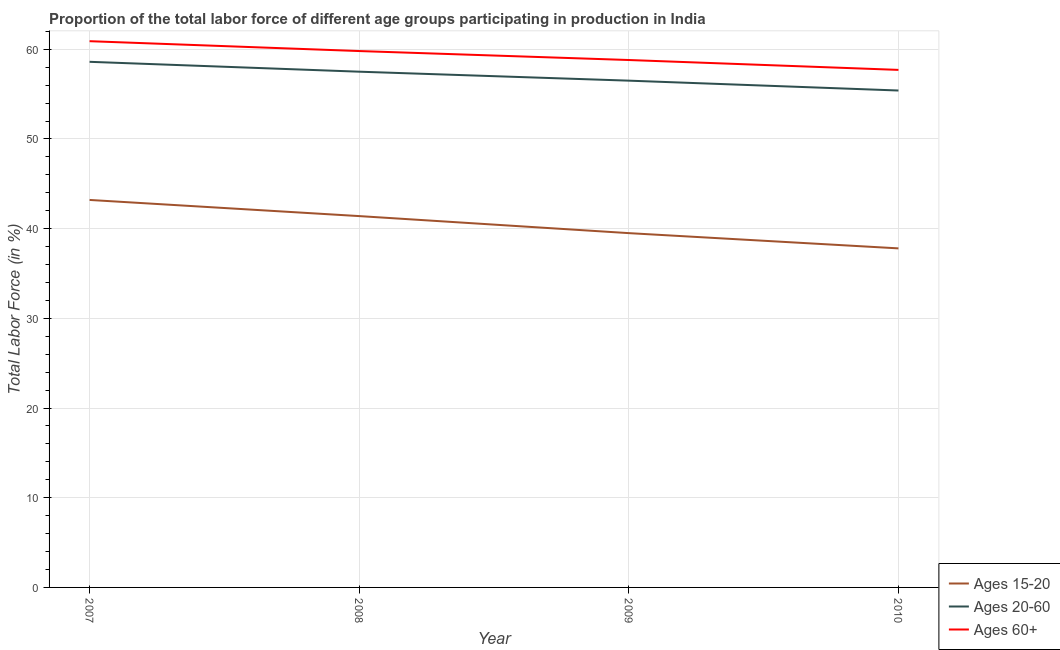How many different coloured lines are there?
Offer a terse response. 3. What is the percentage of labor force within the age group 20-60 in 2007?
Your answer should be compact. 58.6. Across all years, what is the maximum percentage of labor force within the age group 15-20?
Your answer should be very brief. 43.2. Across all years, what is the minimum percentage of labor force within the age group 20-60?
Your answer should be very brief. 55.4. In which year was the percentage of labor force above age 60 maximum?
Provide a succinct answer. 2007. In which year was the percentage of labor force within the age group 15-20 minimum?
Provide a succinct answer. 2010. What is the total percentage of labor force above age 60 in the graph?
Ensure brevity in your answer.  237.2. What is the difference between the percentage of labor force within the age group 20-60 in 2008 and that in 2010?
Your response must be concise. 2.1. What is the difference between the percentage of labor force within the age group 20-60 in 2010 and the percentage of labor force within the age group 15-20 in 2009?
Provide a succinct answer. 15.9. What is the average percentage of labor force within the age group 20-60 per year?
Give a very brief answer. 57. In the year 2010, what is the difference between the percentage of labor force above age 60 and percentage of labor force within the age group 20-60?
Keep it short and to the point. 2.3. In how many years, is the percentage of labor force within the age group 20-60 greater than 2 %?
Offer a terse response. 4. What is the ratio of the percentage of labor force within the age group 15-20 in 2007 to that in 2008?
Give a very brief answer. 1.04. Is the difference between the percentage of labor force within the age group 20-60 in 2008 and 2010 greater than the difference between the percentage of labor force within the age group 15-20 in 2008 and 2010?
Your response must be concise. No. What is the difference between the highest and the second highest percentage of labor force within the age group 20-60?
Provide a short and direct response. 1.1. What is the difference between the highest and the lowest percentage of labor force above age 60?
Provide a succinct answer. 3.2. In how many years, is the percentage of labor force within the age group 20-60 greater than the average percentage of labor force within the age group 20-60 taken over all years?
Offer a very short reply. 2. Is the percentage of labor force within the age group 15-20 strictly greater than the percentage of labor force above age 60 over the years?
Give a very brief answer. No. How many years are there in the graph?
Give a very brief answer. 4. Does the graph contain any zero values?
Make the answer very short. No. Does the graph contain grids?
Your answer should be compact. Yes. How many legend labels are there?
Your answer should be compact. 3. How are the legend labels stacked?
Ensure brevity in your answer.  Vertical. What is the title of the graph?
Provide a short and direct response. Proportion of the total labor force of different age groups participating in production in India. Does "Errors" appear as one of the legend labels in the graph?
Keep it short and to the point. No. What is the label or title of the X-axis?
Give a very brief answer. Year. What is the label or title of the Y-axis?
Make the answer very short. Total Labor Force (in %). What is the Total Labor Force (in %) in Ages 15-20 in 2007?
Give a very brief answer. 43.2. What is the Total Labor Force (in %) of Ages 20-60 in 2007?
Offer a very short reply. 58.6. What is the Total Labor Force (in %) of Ages 60+ in 2007?
Your response must be concise. 60.9. What is the Total Labor Force (in %) of Ages 15-20 in 2008?
Keep it short and to the point. 41.4. What is the Total Labor Force (in %) in Ages 20-60 in 2008?
Give a very brief answer. 57.5. What is the Total Labor Force (in %) in Ages 60+ in 2008?
Keep it short and to the point. 59.8. What is the Total Labor Force (in %) in Ages 15-20 in 2009?
Provide a short and direct response. 39.5. What is the Total Labor Force (in %) of Ages 20-60 in 2009?
Your answer should be very brief. 56.5. What is the Total Labor Force (in %) of Ages 60+ in 2009?
Give a very brief answer. 58.8. What is the Total Labor Force (in %) of Ages 15-20 in 2010?
Make the answer very short. 37.8. What is the Total Labor Force (in %) of Ages 20-60 in 2010?
Your answer should be compact. 55.4. What is the Total Labor Force (in %) of Ages 60+ in 2010?
Offer a very short reply. 57.7. Across all years, what is the maximum Total Labor Force (in %) in Ages 15-20?
Make the answer very short. 43.2. Across all years, what is the maximum Total Labor Force (in %) of Ages 20-60?
Make the answer very short. 58.6. Across all years, what is the maximum Total Labor Force (in %) of Ages 60+?
Give a very brief answer. 60.9. Across all years, what is the minimum Total Labor Force (in %) in Ages 15-20?
Provide a succinct answer. 37.8. Across all years, what is the minimum Total Labor Force (in %) in Ages 20-60?
Provide a short and direct response. 55.4. Across all years, what is the minimum Total Labor Force (in %) in Ages 60+?
Make the answer very short. 57.7. What is the total Total Labor Force (in %) of Ages 15-20 in the graph?
Offer a very short reply. 161.9. What is the total Total Labor Force (in %) in Ages 20-60 in the graph?
Give a very brief answer. 228. What is the total Total Labor Force (in %) of Ages 60+ in the graph?
Offer a terse response. 237.2. What is the difference between the Total Labor Force (in %) in Ages 15-20 in 2007 and that in 2008?
Offer a very short reply. 1.8. What is the difference between the Total Labor Force (in %) of Ages 20-60 in 2007 and that in 2009?
Your answer should be very brief. 2.1. What is the difference between the Total Labor Force (in %) in Ages 60+ in 2007 and that in 2009?
Make the answer very short. 2.1. What is the difference between the Total Labor Force (in %) of Ages 15-20 in 2007 and that in 2010?
Provide a succinct answer. 5.4. What is the difference between the Total Labor Force (in %) of Ages 20-60 in 2007 and that in 2010?
Your response must be concise. 3.2. What is the difference between the Total Labor Force (in %) in Ages 60+ in 2007 and that in 2010?
Provide a succinct answer. 3.2. What is the difference between the Total Labor Force (in %) in Ages 60+ in 2008 and that in 2009?
Offer a very short reply. 1. What is the difference between the Total Labor Force (in %) of Ages 15-20 in 2008 and that in 2010?
Make the answer very short. 3.6. What is the difference between the Total Labor Force (in %) in Ages 20-60 in 2008 and that in 2010?
Give a very brief answer. 2.1. What is the difference between the Total Labor Force (in %) in Ages 60+ in 2008 and that in 2010?
Offer a very short reply. 2.1. What is the difference between the Total Labor Force (in %) of Ages 15-20 in 2007 and the Total Labor Force (in %) of Ages 20-60 in 2008?
Make the answer very short. -14.3. What is the difference between the Total Labor Force (in %) in Ages 15-20 in 2007 and the Total Labor Force (in %) in Ages 60+ in 2008?
Keep it short and to the point. -16.6. What is the difference between the Total Labor Force (in %) in Ages 20-60 in 2007 and the Total Labor Force (in %) in Ages 60+ in 2008?
Give a very brief answer. -1.2. What is the difference between the Total Labor Force (in %) of Ages 15-20 in 2007 and the Total Labor Force (in %) of Ages 60+ in 2009?
Provide a short and direct response. -15.6. What is the difference between the Total Labor Force (in %) in Ages 15-20 in 2007 and the Total Labor Force (in %) in Ages 60+ in 2010?
Your answer should be compact. -14.5. What is the difference between the Total Labor Force (in %) of Ages 15-20 in 2008 and the Total Labor Force (in %) of Ages 20-60 in 2009?
Make the answer very short. -15.1. What is the difference between the Total Labor Force (in %) of Ages 15-20 in 2008 and the Total Labor Force (in %) of Ages 60+ in 2009?
Provide a succinct answer. -17.4. What is the difference between the Total Labor Force (in %) in Ages 15-20 in 2008 and the Total Labor Force (in %) in Ages 20-60 in 2010?
Make the answer very short. -14. What is the difference between the Total Labor Force (in %) of Ages 15-20 in 2008 and the Total Labor Force (in %) of Ages 60+ in 2010?
Ensure brevity in your answer.  -16.3. What is the difference between the Total Labor Force (in %) in Ages 15-20 in 2009 and the Total Labor Force (in %) in Ages 20-60 in 2010?
Offer a very short reply. -15.9. What is the difference between the Total Labor Force (in %) of Ages 15-20 in 2009 and the Total Labor Force (in %) of Ages 60+ in 2010?
Offer a terse response. -18.2. What is the difference between the Total Labor Force (in %) in Ages 20-60 in 2009 and the Total Labor Force (in %) in Ages 60+ in 2010?
Provide a short and direct response. -1.2. What is the average Total Labor Force (in %) of Ages 15-20 per year?
Make the answer very short. 40.48. What is the average Total Labor Force (in %) of Ages 60+ per year?
Your answer should be compact. 59.3. In the year 2007, what is the difference between the Total Labor Force (in %) of Ages 15-20 and Total Labor Force (in %) of Ages 20-60?
Your response must be concise. -15.4. In the year 2007, what is the difference between the Total Labor Force (in %) of Ages 15-20 and Total Labor Force (in %) of Ages 60+?
Offer a very short reply. -17.7. In the year 2008, what is the difference between the Total Labor Force (in %) in Ages 15-20 and Total Labor Force (in %) in Ages 20-60?
Provide a succinct answer. -16.1. In the year 2008, what is the difference between the Total Labor Force (in %) of Ages 15-20 and Total Labor Force (in %) of Ages 60+?
Ensure brevity in your answer.  -18.4. In the year 2008, what is the difference between the Total Labor Force (in %) in Ages 20-60 and Total Labor Force (in %) in Ages 60+?
Offer a terse response. -2.3. In the year 2009, what is the difference between the Total Labor Force (in %) in Ages 15-20 and Total Labor Force (in %) in Ages 60+?
Ensure brevity in your answer.  -19.3. In the year 2009, what is the difference between the Total Labor Force (in %) in Ages 20-60 and Total Labor Force (in %) in Ages 60+?
Make the answer very short. -2.3. In the year 2010, what is the difference between the Total Labor Force (in %) in Ages 15-20 and Total Labor Force (in %) in Ages 20-60?
Your answer should be compact. -17.6. In the year 2010, what is the difference between the Total Labor Force (in %) of Ages 15-20 and Total Labor Force (in %) of Ages 60+?
Offer a very short reply. -19.9. What is the ratio of the Total Labor Force (in %) of Ages 15-20 in 2007 to that in 2008?
Keep it short and to the point. 1.04. What is the ratio of the Total Labor Force (in %) in Ages 20-60 in 2007 to that in 2008?
Offer a terse response. 1.02. What is the ratio of the Total Labor Force (in %) in Ages 60+ in 2007 to that in 2008?
Keep it short and to the point. 1.02. What is the ratio of the Total Labor Force (in %) in Ages 15-20 in 2007 to that in 2009?
Your response must be concise. 1.09. What is the ratio of the Total Labor Force (in %) in Ages 20-60 in 2007 to that in 2009?
Make the answer very short. 1.04. What is the ratio of the Total Labor Force (in %) of Ages 60+ in 2007 to that in 2009?
Provide a short and direct response. 1.04. What is the ratio of the Total Labor Force (in %) in Ages 20-60 in 2007 to that in 2010?
Provide a short and direct response. 1.06. What is the ratio of the Total Labor Force (in %) in Ages 60+ in 2007 to that in 2010?
Your response must be concise. 1.06. What is the ratio of the Total Labor Force (in %) of Ages 15-20 in 2008 to that in 2009?
Provide a succinct answer. 1.05. What is the ratio of the Total Labor Force (in %) of Ages 20-60 in 2008 to that in 2009?
Your answer should be very brief. 1.02. What is the ratio of the Total Labor Force (in %) in Ages 60+ in 2008 to that in 2009?
Give a very brief answer. 1.02. What is the ratio of the Total Labor Force (in %) of Ages 15-20 in 2008 to that in 2010?
Your answer should be compact. 1.1. What is the ratio of the Total Labor Force (in %) in Ages 20-60 in 2008 to that in 2010?
Ensure brevity in your answer.  1.04. What is the ratio of the Total Labor Force (in %) in Ages 60+ in 2008 to that in 2010?
Your answer should be very brief. 1.04. What is the ratio of the Total Labor Force (in %) in Ages 15-20 in 2009 to that in 2010?
Make the answer very short. 1.04. What is the ratio of the Total Labor Force (in %) of Ages 20-60 in 2009 to that in 2010?
Give a very brief answer. 1.02. What is the ratio of the Total Labor Force (in %) of Ages 60+ in 2009 to that in 2010?
Offer a terse response. 1.02. What is the difference between the highest and the lowest Total Labor Force (in %) of Ages 15-20?
Provide a short and direct response. 5.4. What is the difference between the highest and the lowest Total Labor Force (in %) of Ages 20-60?
Give a very brief answer. 3.2. 